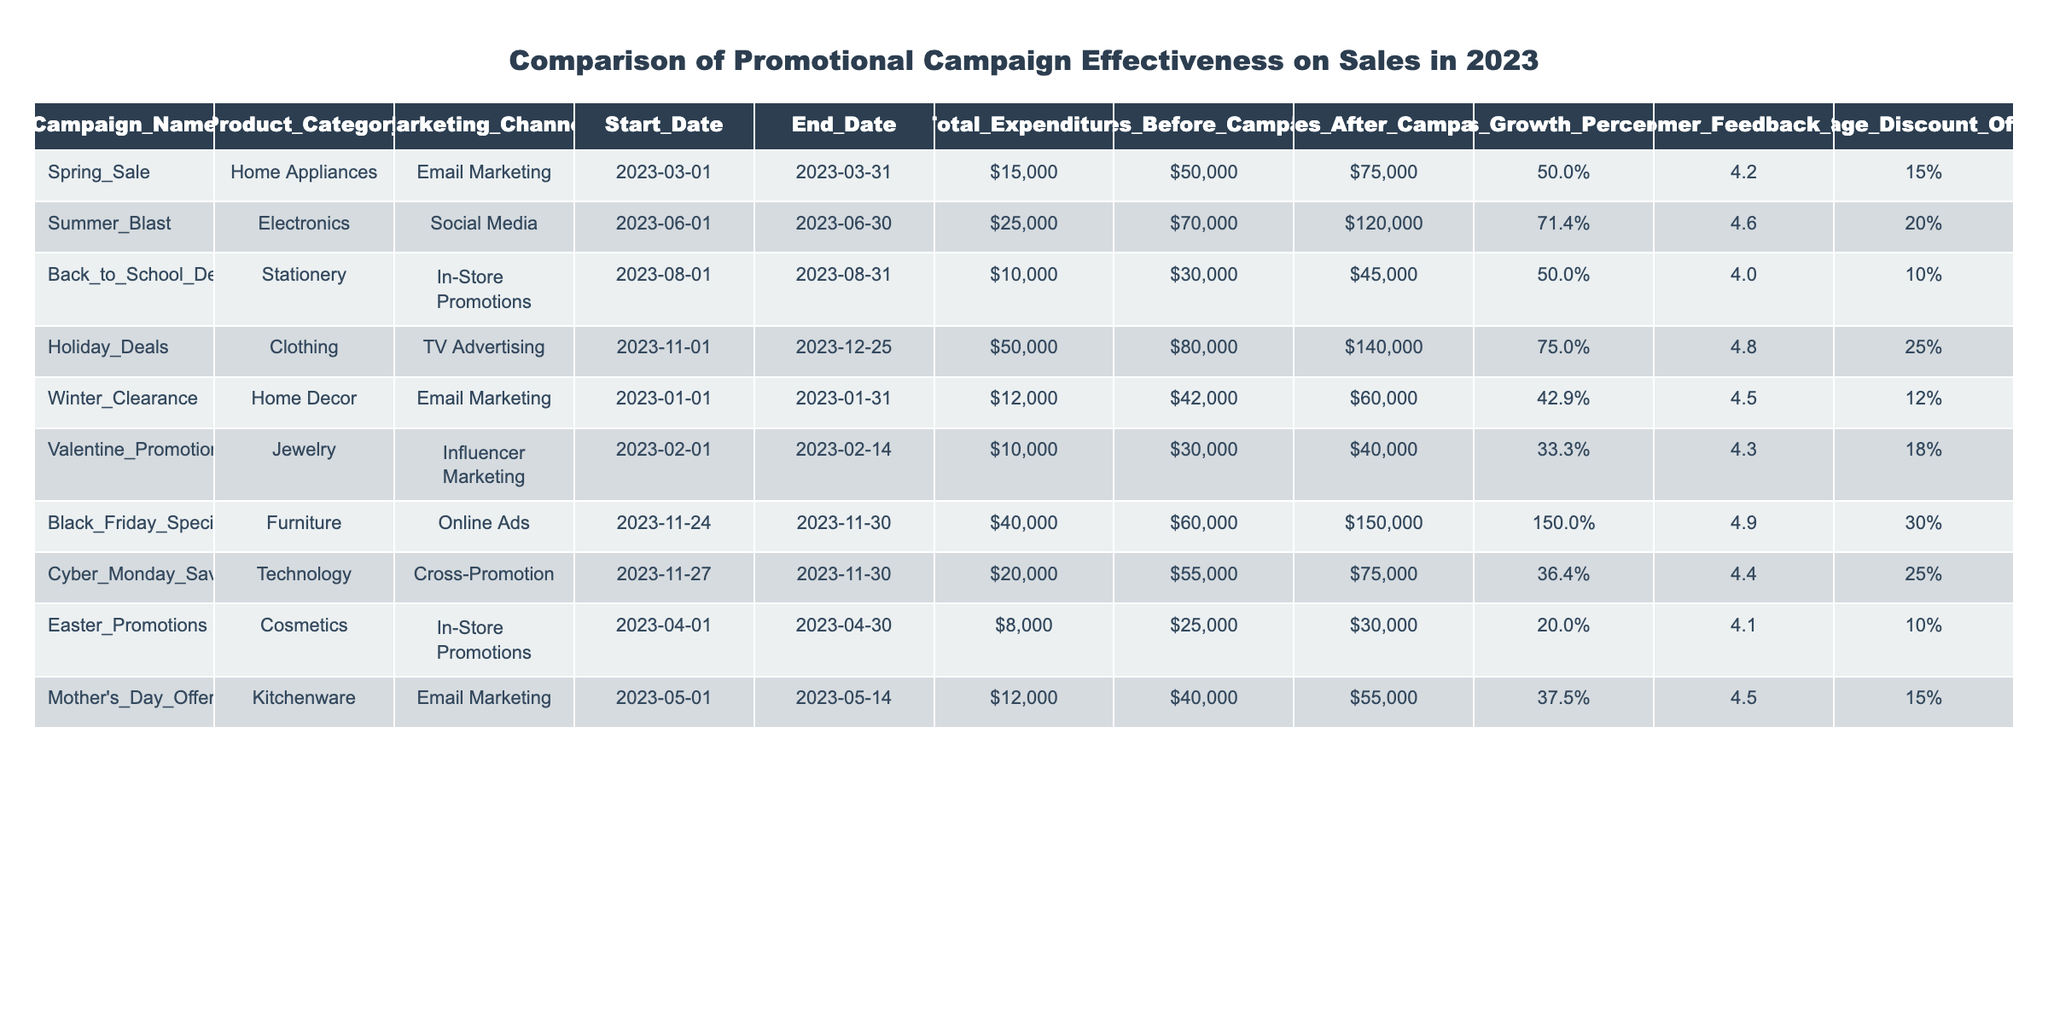What is the total expenditure for the Holiday Deals campaign? The table shows the "Total_Expenditure" column. For the Holiday Deals campaign, the value listed is $50,000.
Answer: $50,000 What was the Sales Growth Percentage for the Summer Blast campaign? The "Sales Growth Percentage" for the Summer Blast campaign is directly available in the table, and it is listed as 71.4%.
Answer: 71.4% Which marketing channel had the highest Customer Feedback Score? The "Customer Feedback Score" values for the marketing channels are listed. The maximum score is 4.9, which belongs to the Black Friday Special campaign.
Answer: Black Friday Special How much was spent on the Valentine's Promotions campaign compared to the Mother's Day Offers? The total expenditures are found in the "Total Expenditure" column: Valentine's Promotions spent $10,000 and Mother's Day Offers spent $12,000. The difference is $12,000 - $10,000 = $2,000.
Answer: $2,000 What was the average discount offered across all campaigns? To find the average discount, sum all the "Average Discount Offered" values: 15% + 20% + 10% + 25% + 12% + 18% + 30% + 25% + 10% + 15% =  15.5%. Then divide by 10 (the total number of campaigns).
Answer: 15.5% Did the Back to School Deals campaign have a higher sales growth percentage than the Valentine's Promotions campaign? The Sales Growth Percentage for Back to School Deals is 50%, and for Valentine's Promotions, it is 33.3%. Since 50% is greater than 33.3%, the statement is true.
Answer: Yes Which campaign achieved the highest sales after the campaign and what was the amount? The "Sales After Campaign" column lists the values. The highest sales are from the Black Friday Special campaign, with $150,000 in sales.
Answer: Black Friday Special; $150,000 How much more was the Total Expenditure for the Holiday Deals compared to the Winter Clearance campaign? The total expenditures are $50,000 for Holiday Deals and $12,000 for Winter Clearance. Subtracting these gives $50,000 - $12,000 = $38,000.
Answer: $38,000 Which product category had the lowest average discount offered in their campaigns? The average discounts offered for the campaigns are: Home Appliances (15%), Electronics (20%), Stationery (10%), Clothing (25%), Home Decor (12%), Jewelry (18%), Furniture (30%), Technology (25%), Cosmetics (10%), Kitchenware (15%). The lowest is 10%, which belongs to Stationery and Cosmetics categories.
Answer: Stationery and Cosmetics If we consider only the campaigns that used Email Marketing, what was the average sales growth percentage? The campaigns using Email Marketing are Spring Sale (50%), Winter Clearance (42.86%), and Mother's Day Offers (37.5%). Summing these gives 50 + 42.86 + 37.5 = 130.36 and dividing by 3 gives an average of approximately 43.45%.
Answer: 43.45% What was the sales growth percentage difference between the Holiday Deals and Black Friday Special campaigns? The Sales Growth Percentage for Holiday Deals is 75% and for Black Friday Special is 150%. The difference is 150% - 75% = 75%.
Answer: 75% 